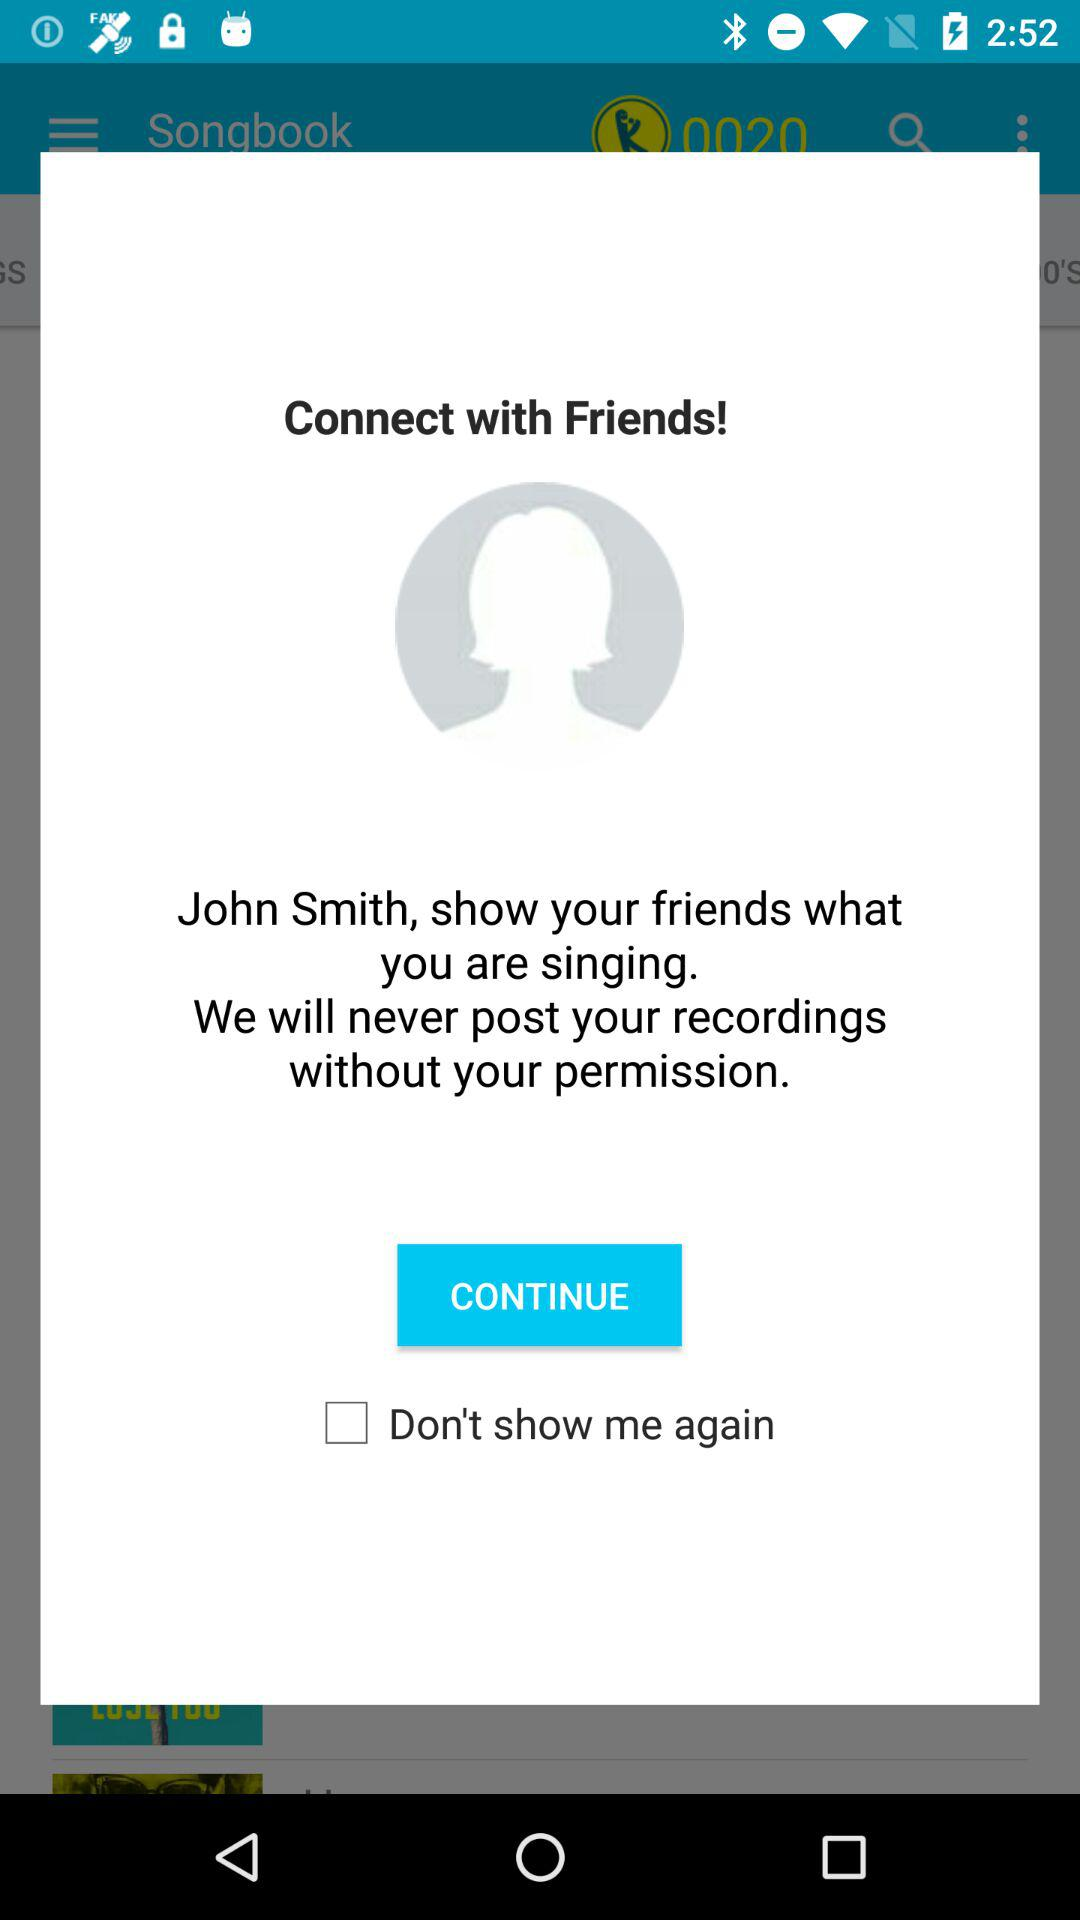What is the one thing the application never posts without our permission? The application will never post your recordings without your permission. 